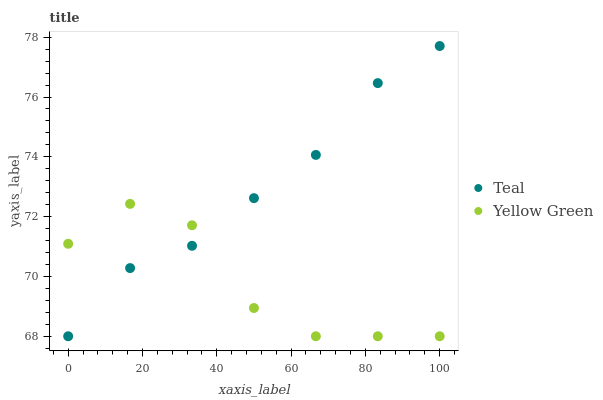Does Yellow Green have the minimum area under the curve?
Answer yes or no. Yes. Does Teal have the maximum area under the curve?
Answer yes or no. Yes. Does Teal have the minimum area under the curve?
Answer yes or no. No. Is Teal the smoothest?
Answer yes or no. Yes. Is Yellow Green the roughest?
Answer yes or no. Yes. Is Teal the roughest?
Answer yes or no. No. Does Yellow Green have the lowest value?
Answer yes or no. Yes. Does Teal have the highest value?
Answer yes or no. Yes. Does Yellow Green intersect Teal?
Answer yes or no. Yes. Is Yellow Green less than Teal?
Answer yes or no. No. Is Yellow Green greater than Teal?
Answer yes or no. No. 